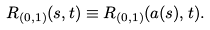<formula> <loc_0><loc_0><loc_500><loc_500>R _ { ( 0 , 1 ) } ( s , t ) \equiv R _ { ( 0 , 1 ) } ( a ( s ) , t ) .</formula> 